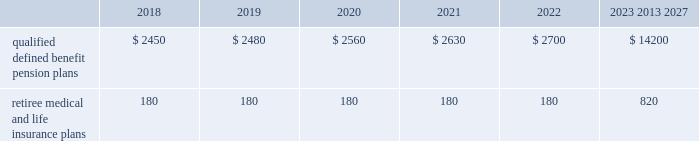U.s .
Equity securities and international equity securities categorized as level 1 are traded on active national and international exchanges and are valued at their closing prices on the last trading day of the year .
For u.s .
Equity securities and international equity securities not traded on an active exchange , or if the closing price is not available , the trustee obtains indicative quotes from a pricing vendor , broker or investment manager .
These securities are categorized as level 2 if the custodian obtains corroborated quotes from a pricing vendor or categorized as level 3 if the custodian obtains uncorroborated quotes from a broker or investment manager .
Commingled equity funds categorized as level 1 are traded on active national and international exchanges and are valued at their closing prices on the last trading day of the year .
For commingled equity funds not traded on an active exchange , or if the closing price is not available , the trustee obtains indicative quotes from a pricing vendor , broker or investment manager .
These securities are categorized as level 2 if the custodian obtains corroborated quotes from a pricing vendor .
Fixed income investments categorized as level 2 are valued by the trustee using pricing models that use verifiable observable market data ( e.g. , interest rates and yield curves observable at commonly quoted intervals and credit spreads ) , bids provided by brokers or dealers or quoted prices of securities with similar characteristics .
Fixed income investments are categorized at level 3 when valuations using observable inputs are unavailable .
The trustee obtains pricing based on indicative quotes or bid evaluations from vendors , brokers or the investment manager .
Commodities are traded on an active commodity exchange and are valued at their closing prices on the last trading day of the certain commingled equity funds , consisting of equity mutual funds , are valued using the nav.aa thenavaa valuations are based on the underlying investments and typically redeemable within 90 days .
Private equity funds consist of partnership and co-investment funds .
The navaa is based on valuation models of the underlying securities , which includes unobservable inputs that cannot be corroborated using verifiable observable market data .
These funds typically have redemption periods between eight and 12 years .
Real estate funds consist of partnerships , most of which are closed-end funds , for which the navaa is based on valuationmodels and periodic appraisals .
These funds typically have redemption periods between eight and 10 years .
Hedge funds consist of direct hedge funds forwhich thenavaa is generally based on the valuation of the underlying investments .
Redemptions in hedge funds are based on the specific terms of each fund , and generally range from a minimum of one month to several months .
Contributions and expected benefit payments the funding of our qualified defined benefit pension plans is determined in accordance with erisa , as amended by the ppa , and in a manner consistent with cas and internal revenue code rules .
There were no material contributions to our qualified defined benefit pension plans during 2017 .
We will make contributions of $ 5.0 billion to our qualified defined benefit pension plans in 2018 , including required and discretionary contributions.as a result of these contributions , we do not expect any material qualified defined benefit cash funding will be required until 2021.we plan to fund these contributions using a mix of cash on hand and commercial paper .
While we do not anticipate a need to do so , our capital structure and resources would allow us to issue new debt if circumstances change .
The table presents estimated future benefit payments , which reflect expected future employee service , as of december 31 , 2017 ( in millions ) : .
Defined contribution plans wemaintain a number of defined contribution plans , most with 401 ( k ) features , that cover substantially all of our employees .
Under the provisions of our 401 ( k ) plans , wematchmost employees 2019 eligible contributions at rates specified in the plan documents .
Our contributions were $ 613 million in 2017 , $ 617 million in 2016 and $ 393 million in 2015 , the majority of which were funded using our common stock .
Our defined contribution plans held approximately 35.5 million and 36.9 million shares of our common stock as of december 31 , 2017 and 2016. .
In december 2017 what was the ratio of the estimated future benefit payments due after 2023 to the amount due in 2018? 
Computations: (14200 / 2450)
Answer: 5.79592. U.s .
Equity securities and international equity securities categorized as level 1 are traded on active national and international exchanges and are valued at their closing prices on the last trading day of the year .
For u.s .
Equity securities and international equity securities not traded on an active exchange , or if the closing price is not available , the trustee obtains indicative quotes from a pricing vendor , broker or investment manager .
These securities are categorized as level 2 if the custodian obtains corroborated quotes from a pricing vendor or categorized as level 3 if the custodian obtains uncorroborated quotes from a broker or investment manager .
Commingled equity funds categorized as level 1 are traded on active national and international exchanges and are valued at their closing prices on the last trading day of the year .
For commingled equity funds not traded on an active exchange , or if the closing price is not available , the trustee obtains indicative quotes from a pricing vendor , broker or investment manager .
These securities are categorized as level 2 if the custodian obtains corroborated quotes from a pricing vendor .
Fixed income investments categorized as level 2 are valued by the trustee using pricing models that use verifiable observable market data ( e.g. , interest rates and yield curves observable at commonly quoted intervals and credit spreads ) , bids provided by brokers or dealers or quoted prices of securities with similar characteristics .
Fixed income investments are categorized at level 3 when valuations using observable inputs are unavailable .
The trustee obtains pricing based on indicative quotes or bid evaluations from vendors , brokers or the investment manager .
Commodities are traded on an active commodity exchange and are valued at their closing prices on the last trading day of the certain commingled equity funds , consisting of equity mutual funds , are valued using the nav.aa thenavaa valuations are based on the underlying investments and typically redeemable within 90 days .
Private equity funds consist of partnership and co-investment funds .
The navaa is based on valuation models of the underlying securities , which includes unobservable inputs that cannot be corroborated using verifiable observable market data .
These funds typically have redemption periods between eight and 12 years .
Real estate funds consist of partnerships , most of which are closed-end funds , for which the navaa is based on valuationmodels and periodic appraisals .
These funds typically have redemption periods between eight and 10 years .
Hedge funds consist of direct hedge funds forwhich thenavaa is generally based on the valuation of the underlying investments .
Redemptions in hedge funds are based on the specific terms of each fund , and generally range from a minimum of one month to several months .
Contributions and expected benefit payments the funding of our qualified defined benefit pension plans is determined in accordance with erisa , as amended by the ppa , and in a manner consistent with cas and internal revenue code rules .
There were no material contributions to our qualified defined benefit pension plans during 2017 .
We will make contributions of $ 5.0 billion to our qualified defined benefit pension plans in 2018 , including required and discretionary contributions.as a result of these contributions , we do not expect any material qualified defined benefit cash funding will be required until 2021.we plan to fund these contributions using a mix of cash on hand and commercial paper .
While we do not anticipate a need to do so , our capital structure and resources would allow us to issue new debt if circumstances change .
The table presents estimated future benefit payments , which reflect expected future employee service , as of december 31 , 2017 ( in millions ) : .
Defined contribution plans wemaintain a number of defined contribution plans , most with 401 ( k ) features , that cover substantially all of our employees .
Under the provisions of our 401 ( k ) plans , wematchmost employees 2019 eligible contributions at rates specified in the plan documents .
Our contributions were $ 613 million in 2017 , $ 617 million in 2016 and $ 393 million in 2015 , the majority of which were funded using our common stock .
Our defined contribution plans held approximately 35.5 million and 36.9 million shares of our common stock as of december 31 , 2017 and 2016. .
What is the change in millions of qualified defined benefit pension plans expected payments from 2019 to 2020? 
Computations: (2560 - 2480)
Answer: 80.0. 